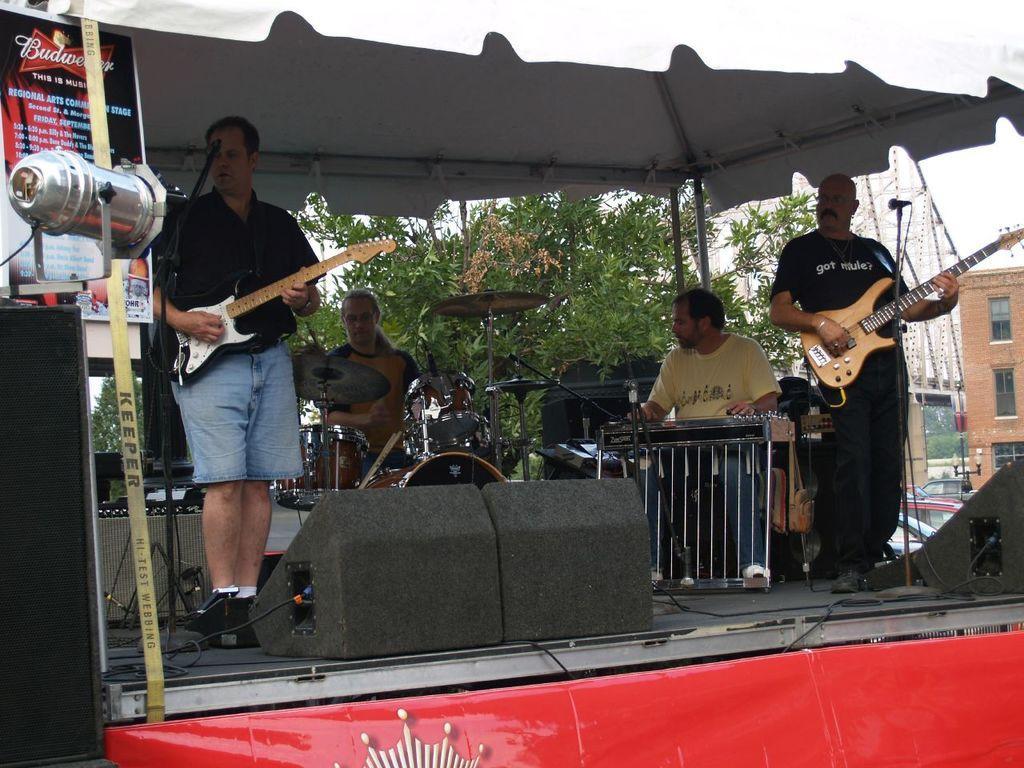Describe this image in one or two sentences. In this picture we can see four persons playing musical instruments such as guitar, piano, drums and they are on stage and in the background we can see trees, buildings with windows, car, banners. 